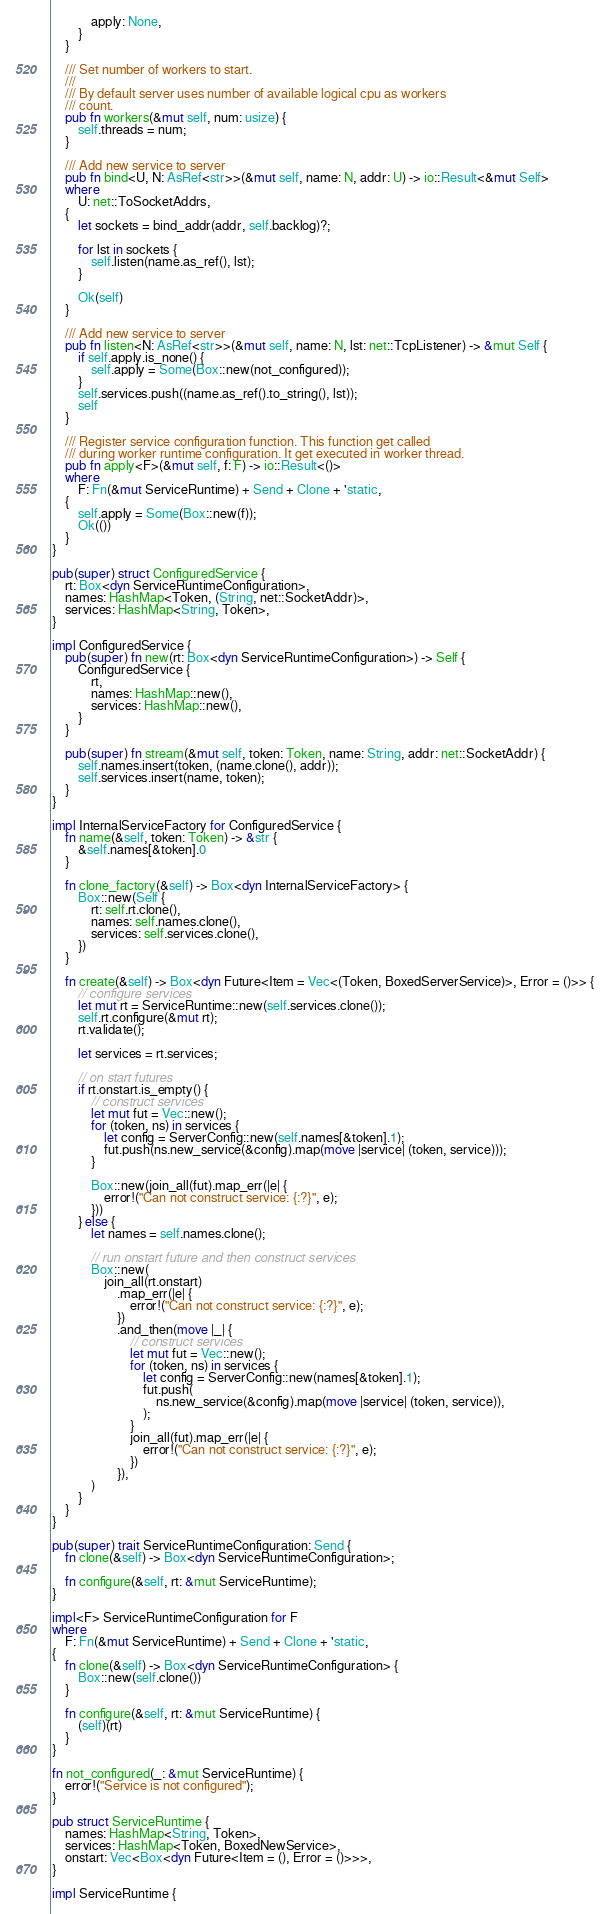<code> <loc_0><loc_0><loc_500><loc_500><_Rust_>            apply: None,
        }
    }

    /// Set number of workers to start.
    ///
    /// By default server uses number of available logical cpu as workers
    /// count.
    pub fn workers(&mut self, num: usize) {
        self.threads = num;
    }

    /// Add new service to server
    pub fn bind<U, N: AsRef<str>>(&mut self, name: N, addr: U) -> io::Result<&mut Self>
    where
        U: net::ToSocketAddrs,
    {
        let sockets = bind_addr(addr, self.backlog)?;

        for lst in sockets {
            self.listen(name.as_ref(), lst);
        }

        Ok(self)
    }

    /// Add new service to server
    pub fn listen<N: AsRef<str>>(&mut self, name: N, lst: net::TcpListener) -> &mut Self {
        if self.apply.is_none() {
            self.apply = Some(Box::new(not_configured));
        }
        self.services.push((name.as_ref().to_string(), lst));
        self
    }

    /// Register service configuration function. This function get called
    /// during worker runtime configuration. It get executed in worker thread.
    pub fn apply<F>(&mut self, f: F) -> io::Result<()>
    where
        F: Fn(&mut ServiceRuntime) + Send + Clone + 'static,
    {
        self.apply = Some(Box::new(f));
        Ok(())
    }
}

pub(super) struct ConfiguredService {
    rt: Box<dyn ServiceRuntimeConfiguration>,
    names: HashMap<Token, (String, net::SocketAddr)>,
    services: HashMap<String, Token>,
}

impl ConfiguredService {
    pub(super) fn new(rt: Box<dyn ServiceRuntimeConfiguration>) -> Self {
        ConfiguredService {
            rt,
            names: HashMap::new(),
            services: HashMap::new(),
        }
    }

    pub(super) fn stream(&mut self, token: Token, name: String, addr: net::SocketAddr) {
        self.names.insert(token, (name.clone(), addr));
        self.services.insert(name, token);
    }
}

impl InternalServiceFactory for ConfiguredService {
    fn name(&self, token: Token) -> &str {
        &self.names[&token].0
    }

    fn clone_factory(&self) -> Box<dyn InternalServiceFactory> {
        Box::new(Self {
            rt: self.rt.clone(),
            names: self.names.clone(),
            services: self.services.clone(),
        })
    }

    fn create(&self) -> Box<dyn Future<Item = Vec<(Token, BoxedServerService)>, Error = ()>> {
        // configure services
        let mut rt = ServiceRuntime::new(self.services.clone());
        self.rt.configure(&mut rt);
        rt.validate();

        let services = rt.services;

        // on start futures
        if rt.onstart.is_empty() {
            // construct services
            let mut fut = Vec::new();
            for (token, ns) in services {
                let config = ServerConfig::new(self.names[&token].1);
                fut.push(ns.new_service(&config).map(move |service| (token, service)));
            }

            Box::new(join_all(fut).map_err(|e| {
                error!("Can not construct service: {:?}", e);
            }))
        } else {
            let names = self.names.clone();

            // run onstart future and then construct services
            Box::new(
                join_all(rt.onstart)
                    .map_err(|e| {
                        error!("Can not construct service: {:?}", e);
                    })
                    .and_then(move |_| {
                        // construct services
                        let mut fut = Vec::new();
                        for (token, ns) in services {
                            let config = ServerConfig::new(names[&token].1);
                            fut.push(
                                ns.new_service(&config).map(move |service| (token, service)),
                            );
                        }
                        join_all(fut).map_err(|e| {
                            error!("Can not construct service: {:?}", e);
                        })
                    }),
            )
        }
    }
}

pub(super) trait ServiceRuntimeConfiguration: Send {
    fn clone(&self) -> Box<dyn ServiceRuntimeConfiguration>;

    fn configure(&self, rt: &mut ServiceRuntime);
}

impl<F> ServiceRuntimeConfiguration for F
where
    F: Fn(&mut ServiceRuntime) + Send + Clone + 'static,
{
    fn clone(&self) -> Box<dyn ServiceRuntimeConfiguration> {
        Box::new(self.clone())
    }

    fn configure(&self, rt: &mut ServiceRuntime) {
        (self)(rt)
    }
}

fn not_configured(_: &mut ServiceRuntime) {
    error!("Service is not configured");
}

pub struct ServiceRuntime {
    names: HashMap<String, Token>,
    services: HashMap<Token, BoxedNewService>,
    onstart: Vec<Box<dyn Future<Item = (), Error = ()>>>,
}

impl ServiceRuntime {</code> 